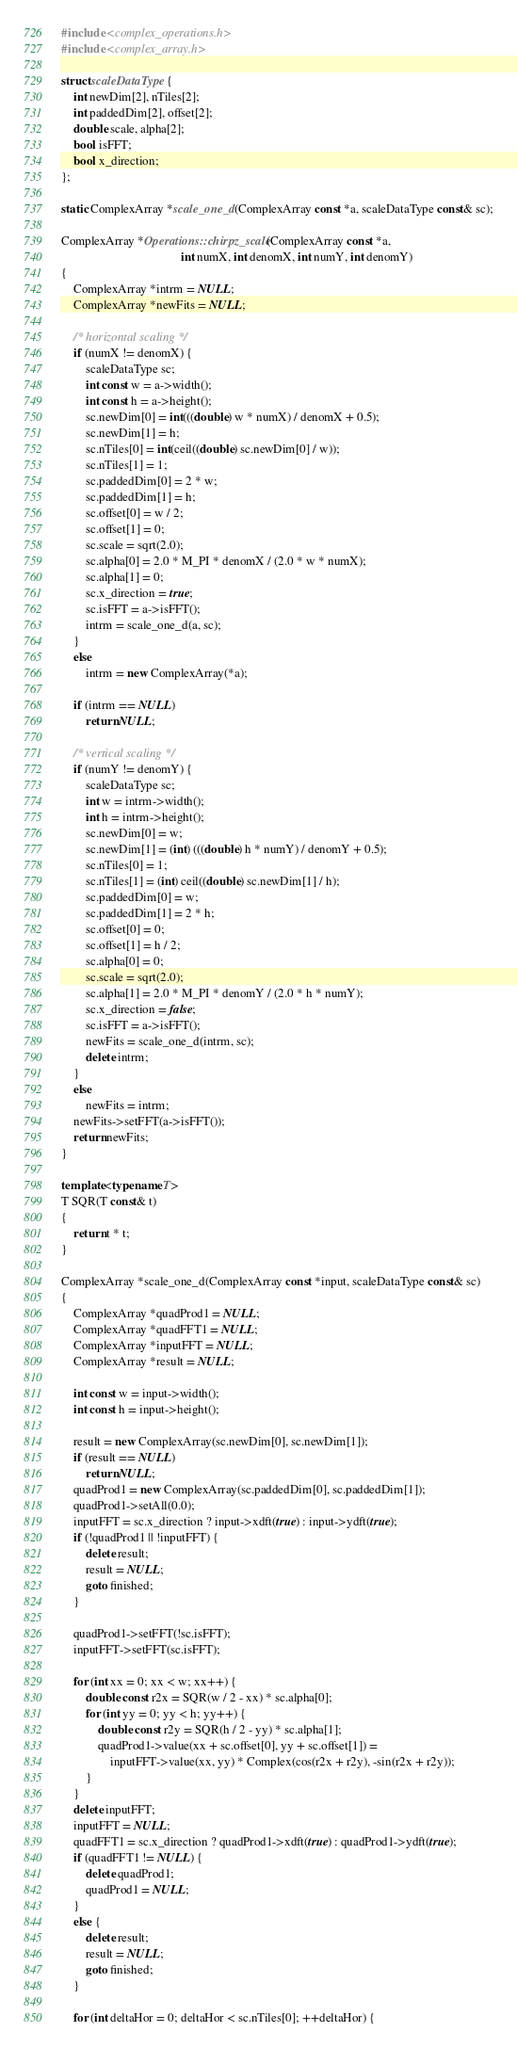<code> <loc_0><loc_0><loc_500><loc_500><_C++_>
#include <complex_operations.h>
#include <complex_array.h>

struct scaleDataType {
    int newDim[2], nTiles[2];
    int paddedDim[2], offset[2];
    double scale, alpha[2];
    bool isFFT;
    bool x_direction;
};

static ComplexArray *scale_one_d(ComplexArray const *a, scaleDataType const& sc);

ComplexArray *Operations::chirpz_scale(ComplexArray const *a,
                                       int numX, int denomX, int numY, int denomY)
{
    ComplexArray *intrm = NULL;
    ComplexArray *newFits = NULL;

    /* horizontal scaling */
    if (numX != denomX) {
        scaleDataType sc;
        int const w = a->width();
        int const h = a->height();
        sc.newDim[0] = int(((double) w * numX) / denomX + 0.5);
        sc.newDim[1] = h;
        sc.nTiles[0] = int(ceil((double) sc.newDim[0] / w));
        sc.nTiles[1] = 1;
        sc.paddedDim[0] = 2 * w;
        sc.paddedDim[1] = h;
        sc.offset[0] = w / 2;
        sc.offset[1] = 0;
        sc.scale = sqrt(2.0);
        sc.alpha[0] = 2.0 * M_PI * denomX / (2.0 * w * numX);
        sc.alpha[1] = 0;
        sc.x_direction = true;
        sc.isFFT = a->isFFT();
        intrm = scale_one_d(a, sc);
    }
    else
        intrm = new ComplexArray(*a);

    if (intrm == NULL)
        return NULL;

    /* vertical scaling */
    if (numY != denomY) {
        scaleDataType sc;
        int w = intrm->width();
        int h = intrm->height();
        sc.newDim[0] = w;
        sc.newDim[1] = (int) (((double) h * numY) / denomY + 0.5);
        sc.nTiles[0] = 1;
        sc.nTiles[1] = (int) ceil((double) sc.newDim[1] / h);
        sc.paddedDim[0] = w;
        sc.paddedDim[1] = 2 * h;
        sc.offset[0] = 0;
        sc.offset[1] = h / 2;
        sc.alpha[0] = 0;
        sc.scale = sqrt(2.0);
        sc.alpha[1] = 2.0 * M_PI * denomY / (2.0 * h * numY);
        sc.x_direction = false;
        sc.isFFT = a->isFFT();
        newFits = scale_one_d(intrm, sc);
        delete intrm;
    }
    else
        newFits = intrm;
    newFits->setFFT(a->isFFT());
    return newFits;
}

template<typename T>
T SQR(T const& t)
{
    return t * t;
}

ComplexArray *scale_one_d(ComplexArray const *input, scaleDataType const& sc)
{
    ComplexArray *quadProd1 = NULL;
    ComplexArray *quadFFT1 = NULL;
    ComplexArray *inputFFT = NULL;
    ComplexArray *result = NULL;

    int const w = input->width();
    int const h = input->height();

    result = new ComplexArray(sc.newDim[0], sc.newDim[1]);
    if (result == NULL)
        return NULL;
    quadProd1 = new ComplexArray(sc.paddedDim[0], sc.paddedDim[1]);
    quadProd1->setAll(0.0);
    inputFFT = sc.x_direction ? input->xdft(true) : input->ydft(true);
    if (!quadProd1 || !inputFFT) {
        delete result;
        result = NULL;
        goto finished;
    }

    quadProd1->setFFT(!sc.isFFT);
    inputFFT->setFFT(sc.isFFT);

    for (int xx = 0; xx < w; xx++) {
        double const r2x = SQR(w / 2 - xx) * sc.alpha[0];
        for (int yy = 0; yy < h; yy++) {
            double const r2y = SQR(h / 2 - yy) * sc.alpha[1];
            quadProd1->value(xx + sc.offset[0], yy + sc.offset[1]) =
                inputFFT->value(xx, yy) * Complex(cos(r2x + r2y), -sin(r2x + r2y));
        }
    }
    delete inputFFT;
    inputFFT = NULL;
    quadFFT1 = sc.x_direction ? quadProd1->xdft(true) : quadProd1->ydft(true);
    if (quadFFT1 != NULL) {
        delete quadProd1;
        quadProd1 = NULL;
    }
    else {
        delete result;
        result = NULL;
        goto finished;
    }

    for (int deltaHor = 0; deltaHor < sc.nTiles[0]; ++deltaHor) {</code> 